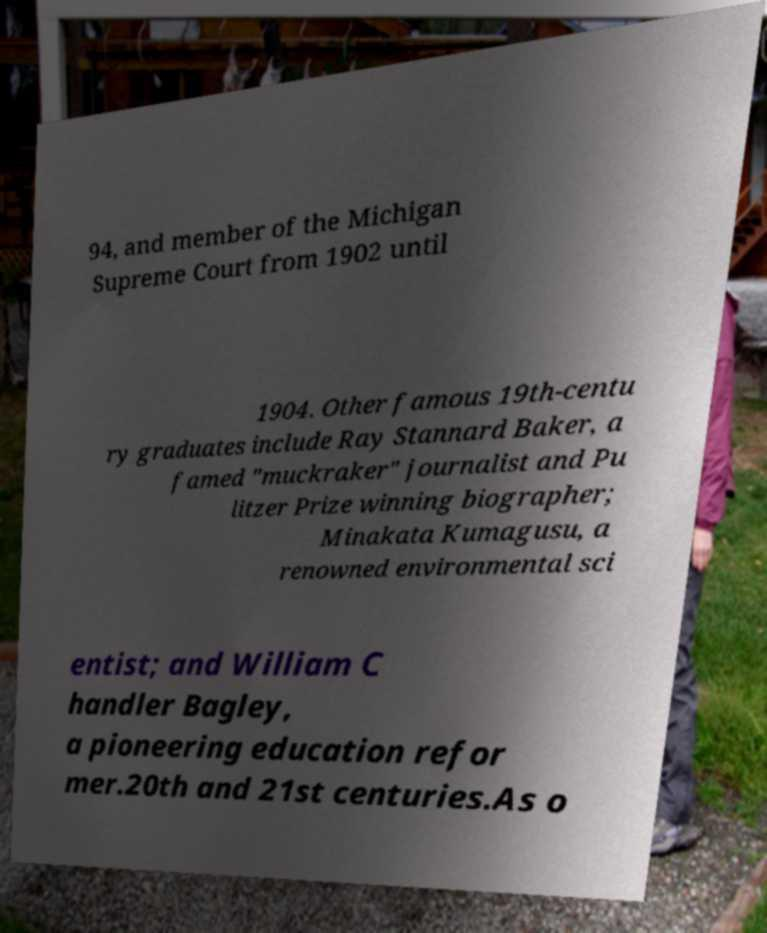I need the written content from this picture converted into text. Can you do that? 94, and member of the Michigan Supreme Court from 1902 until 1904. Other famous 19th-centu ry graduates include Ray Stannard Baker, a famed "muckraker" journalist and Pu litzer Prize winning biographer; Minakata Kumagusu, a renowned environmental sci entist; and William C handler Bagley, a pioneering education refor mer.20th and 21st centuries.As o 